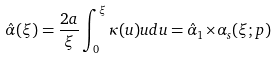Convert formula to latex. <formula><loc_0><loc_0><loc_500><loc_500>\hat { \alpha } ( \xi ) = \frac { 2 a } { \xi } \int _ { 0 } ^ { \xi } { \kappa ( u ) u d u } = \hat { \alpha } _ { 1 } { \times } \alpha _ { s } ( \xi ; { p } )</formula> 